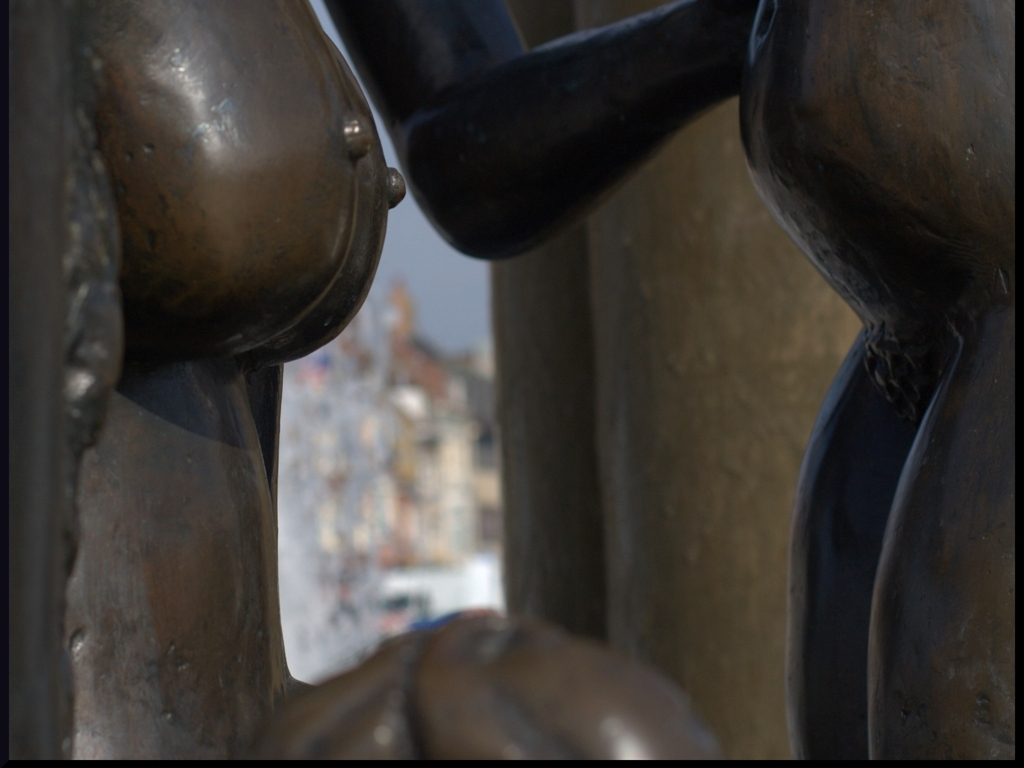What is the focus of this image? The focus of the image is a bronze sculpture with a blurred cityscape in the background. The close-up view accentuates the sculpture's details and texture. Can you describe the mood conveyed by this image? The image conveys a reflective and introspective mood, with the soft lighting and the contemplative positioning of the sculpture suggesting a moment frozen in time. 